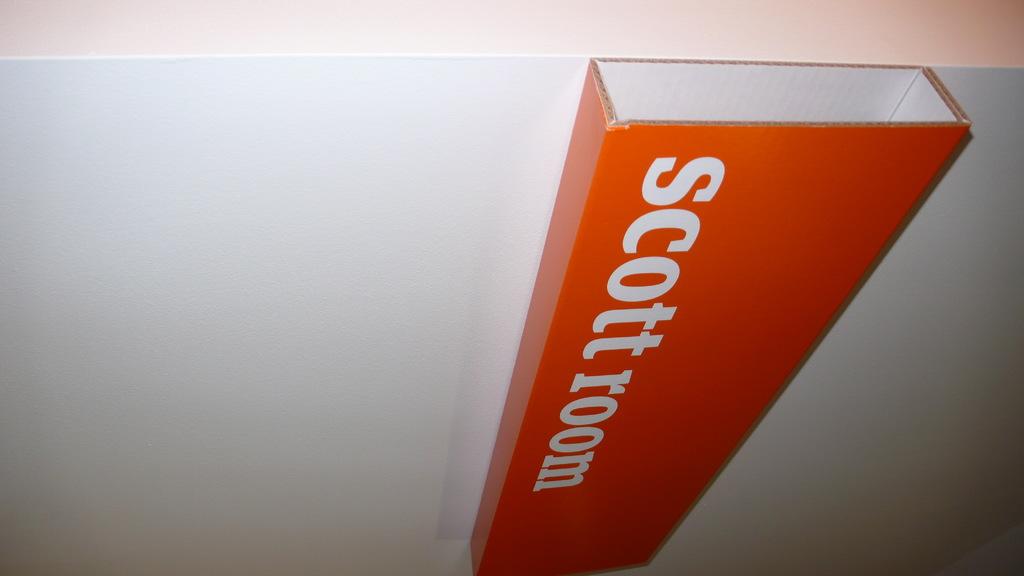What room is it?
Ensure brevity in your answer.  Scott room. What color is the text?
Make the answer very short. White. 